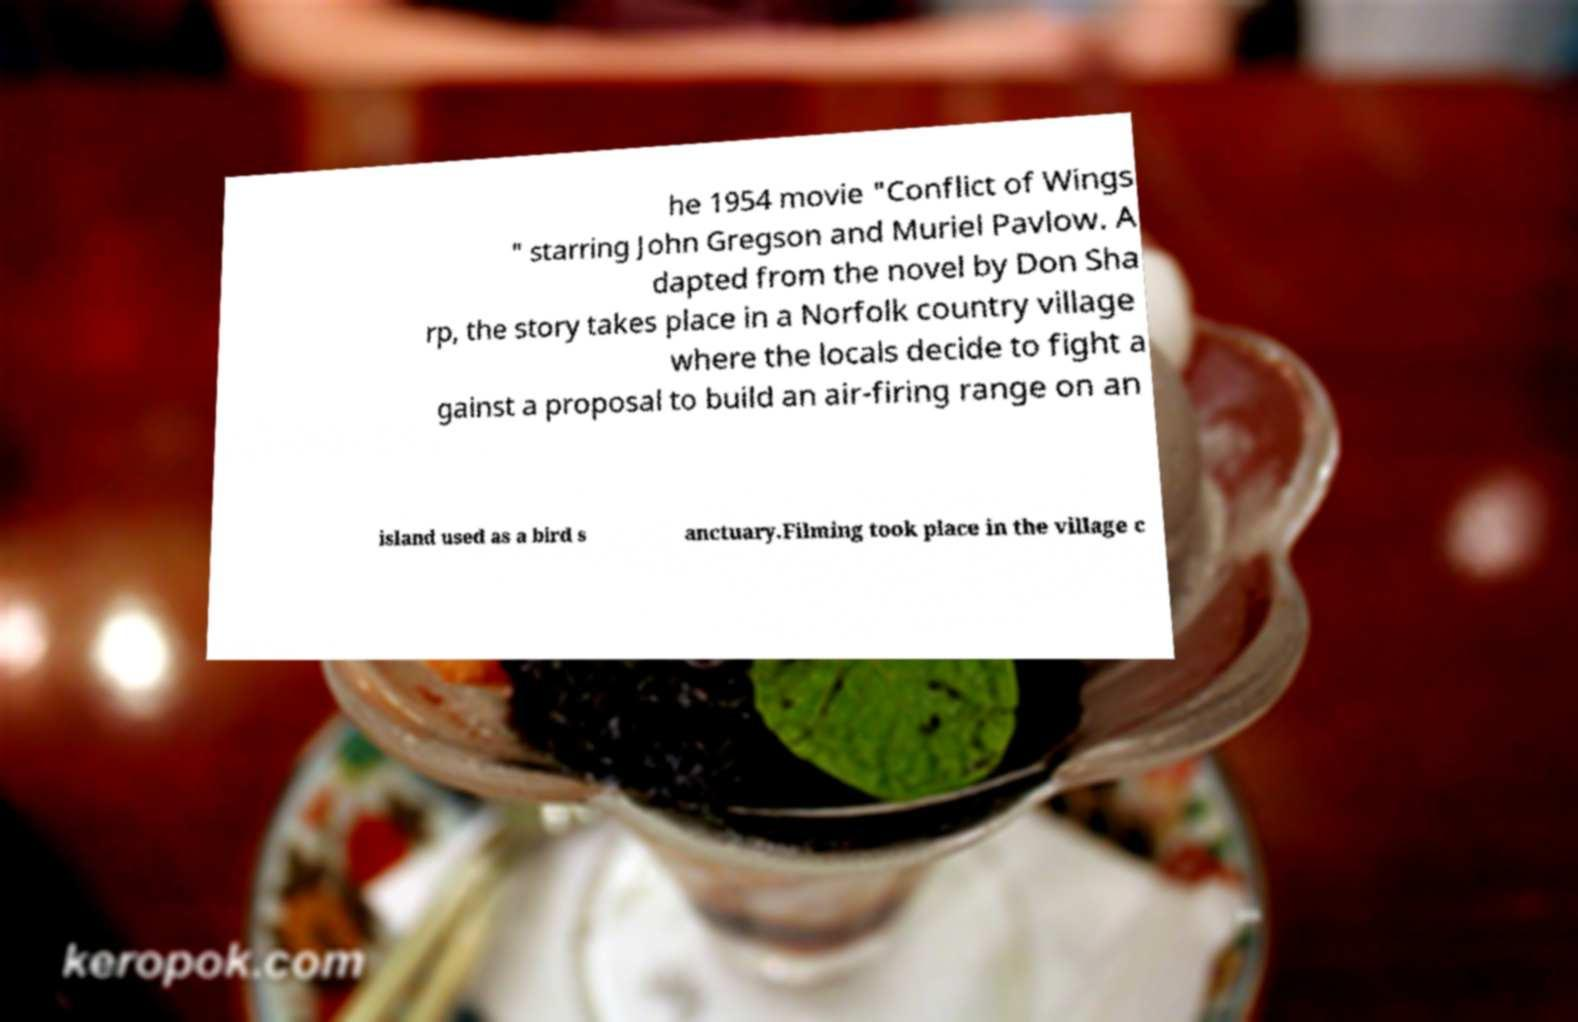Can you accurately transcribe the text from the provided image for me? he 1954 movie "Conflict of Wings " starring John Gregson and Muriel Pavlow. A dapted from the novel by Don Sha rp, the story takes place in a Norfolk country village where the locals decide to fight a gainst a proposal to build an air-firing range on an island used as a bird s anctuary.Filming took place in the village c 